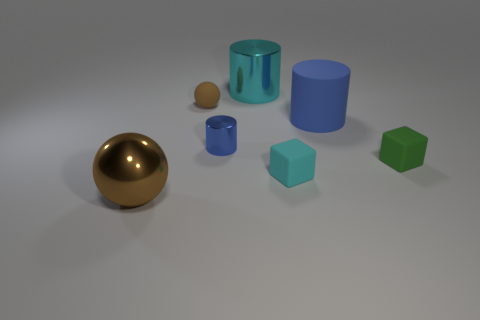There is a matte thing that is in front of the small shiny cylinder and left of the tiny green cube; what size is it?
Offer a terse response. Small. Are there any cyan metallic cylinders?
Offer a very short reply. Yes. What number of other things are there of the same size as the cyan block?
Your answer should be compact. 3. Do the small cube that is left of the large blue matte thing and the metallic thing to the left of the small sphere have the same color?
Your answer should be very brief. No. What is the size of the cyan thing that is the same shape as the small blue object?
Your response must be concise. Large. Is the material of the big object in front of the small cyan matte cube the same as the large cylinder in front of the large metal cylinder?
Offer a terse response. No. What number of metal objects are small red objects or tiny cyan things?
Your answer should be compact. 0. There is a cyan object that is behind the tiny rubber thing that is left of the cyan object in front of the large metal cylinder; what is it made of?
Provide a succinct answer. Metal. There is a brown thing that is on the right side of the metal ball; does it have the same shape as the cyan thing that is in front of the tiny metallic thing?
Offer a terse response. No. There is a cylinder to the left of the cyan object on the left side of the small cyan matte cube; what color is it?
Your answer should be compact. Blue. 